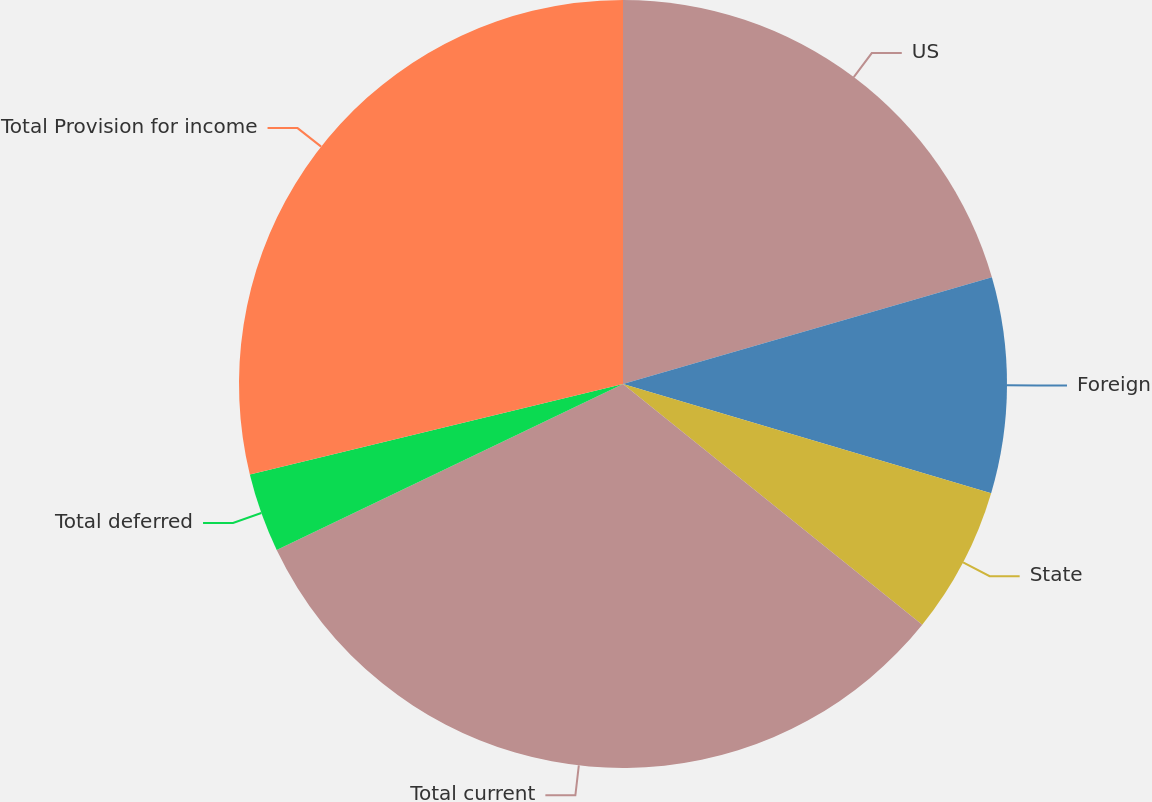<chart> <loc_0><loc_0><loc_500><loc_500><pie_chart><fcel>US<fcel>Foreign<fcel>State<fcel>Total current<fcel>Total deferred<fcel>Total Provision for income<nl><fcel>20.52%<fcel>9.07%<fcel>6.19%<fcel>32.11%<fcel>3.32%<fcel>28.79%<nl></chart> 